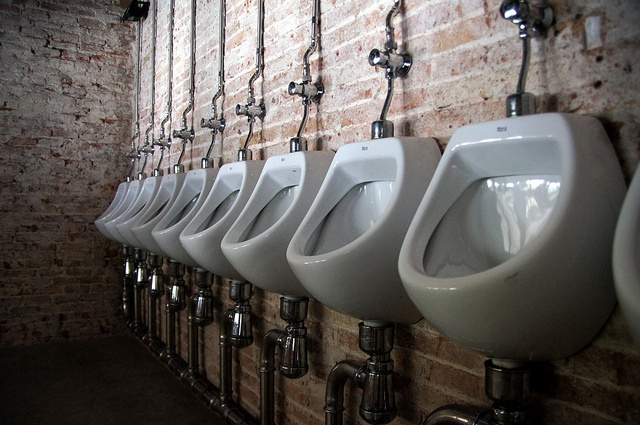Describe the objects in this image and their specific colors. I can see toilet in black, gray, darkgray, and lightgray tones, toilet in black, gray, darkgray, and lightgray tones, toilet in black and gray tones, toilet in black, gray, and darkgray tones, and toilet in black, gray, and darkgray tones in this image. 